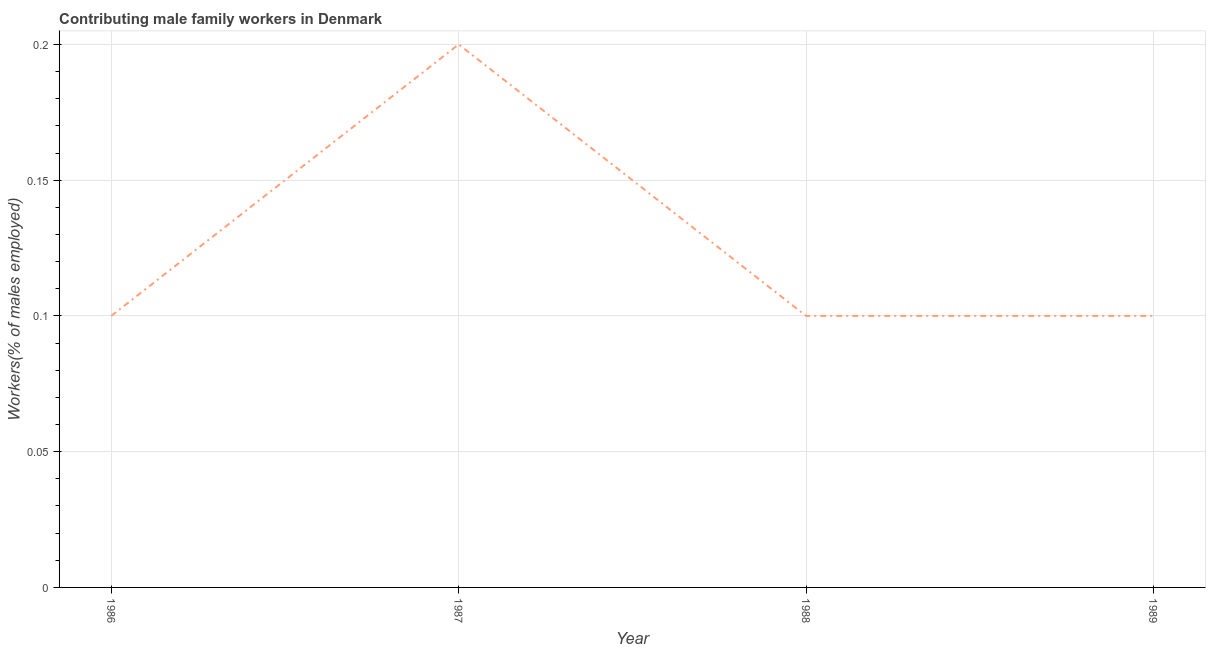What is the contributing male family workers in 1986?
Give a very brief answer. 0.1. Across all years, what is the maximum contributing male family workers?
Your answer should be very brief. 0.2. Across all years, what is the minimum contributing male family workers?
Give a very brief answer. 0.1. In which year was the contributing male family workers maximum?
Give a very brief answer. 1987. In which year was the contributing male family workers minimum?
Offer a very short reply. 1986. What is the sum of the contributing male family workers?
Offer a very short reply. 0.5. What is the difference between the contributing male family workers in 1988 and 1989?
Provide a short and direct response. 0. What is the average contributing male family workers per year?
Provide a succinct answer. 0.13. What is the median contributing male family workers?
Provide a short and direct response. 0.1. Do a majority of the years between 1989 and 1986 (inclusive) have contributing male family workers greater than 0.060000000000000005 %?
Your answer should be very brief. Yes. Is the contributing male family workers in 1986 less than that in 1987?
Ensure brevity in your answer.  Yes. What is the difference between the highest and the second highest contributing male family workers?
Offer a terse response. 0.1. What is the difference between the highest and the lowest contributing male family workers?
Give a very brief answer. 0.1. In how many years, is the contributing male family workers greater than the average contributing male family workers taken over all years?
Offer a very short reply. 1. Does the contributing male family workers monotonically increase over the years?
Make the answer very short. No. How many lines are there?
Your answer should be very brief. 1. Are the values on the major ticks of Y-axis written in scientific E-notation?
Offer a terse response. No. Does the graph contain any zero values?
Your answer should be very brief. No. What is the title of the graph?
Provide a short and direct response. Contributing male family workers in Denmark. What is the label or title of the Y-axis?
Offer a very short reply. Workers(% of males employed). What is the Workers(% of males employed) in 1986?
Give a very brief answer. 0.1. What is the Workers(% of males employed) in 1987?
Give a very brief answer. 0.2. What is the Workers(% of males employed) of 1988?
Provide a succinct answer. 0.1. What is the Workers(% of males employed) in 1989?
Offer a terse response. 0.1. What is the difference between the Workers(% of males employed) in 1986 and 1987?
Provide a short and direct response. -0.1. What is the difference between the Workers(% of males employed) in 1986 and 1988?
Ensure brevity in your answer.  0. What is the difference between the Workers(% of males employed) in 1986 and 1989?
Your answer should be very brief. 0. What is the difference between the Workers(% of males employed) in 1987 and 1988?
Give a very brief answer. 0.1. What is the difference between the Workers(% of males employed) in 1987 and 1989?
Your answer should be compact. 0.1. What is the ratio of the Workers(% of males employed) in 1987 to that in 1988?
Give a very brief answer. 2. 